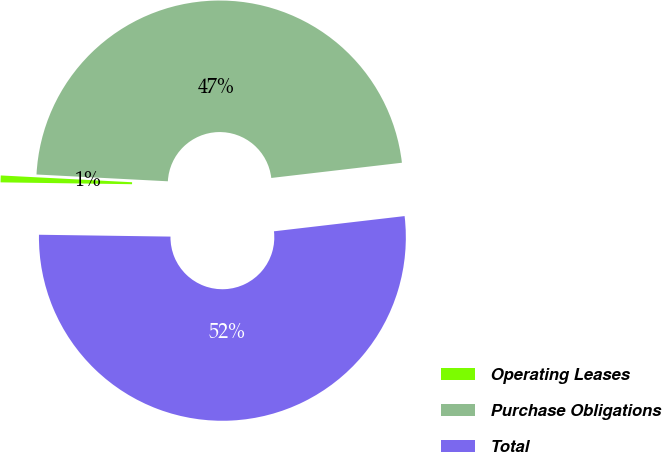Convert chart. <chart><loc_0><loc_0><loc_500><loc_500><pie_chart><fcel>Operating Leases<fcel>Purchase Obligations<fcel>Total<nl><fcel>0.6%<fcel>47.33%<fcel>52.07%<nl></chart> 